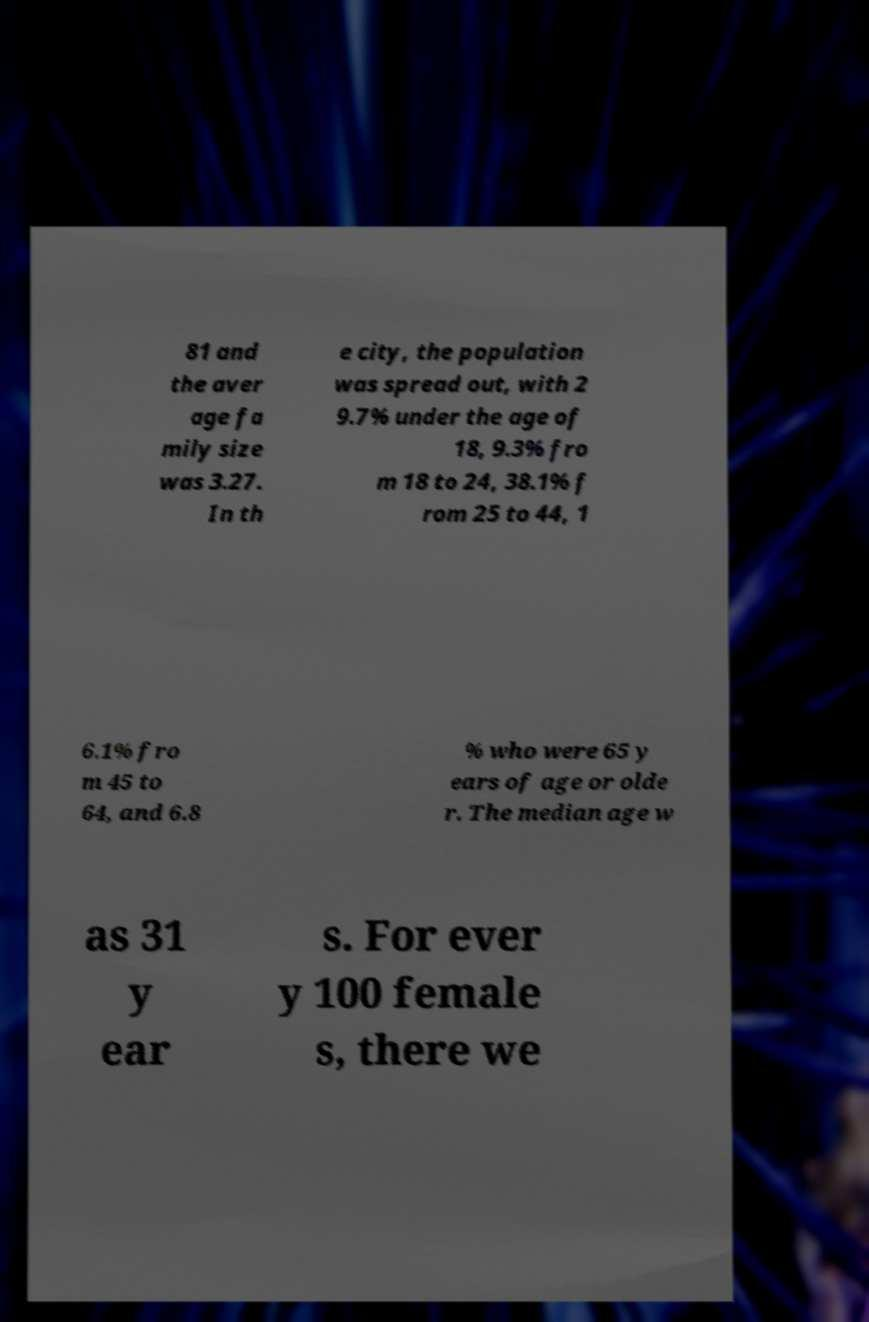Please read and relay the text visible in this image. What does it say? 81 and the aver age fa mily size was 3.27. In th e city, the population was spread out, with 2 9.7% under the age of 18, 9.3% fro m 18 to 24, 38.1% f rom 25 to 44, 1 6.1% fro m 45 to 64, and 6.8 % who were 65 y ears of age or olde r. The median age w as 31 y ear s. For ever y 100 female s, there we 